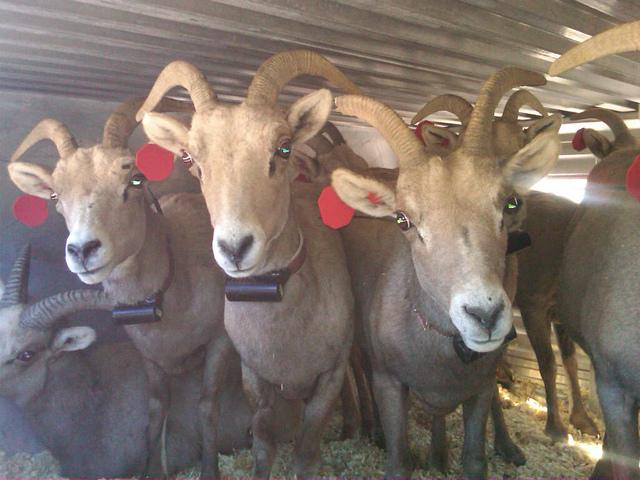What type of loose material is strewn on the floor where the animals are standing? Please explain your reasoning. sawdust. On the ground you can see sawdust which is used to make cleaning the animals waste easier. 